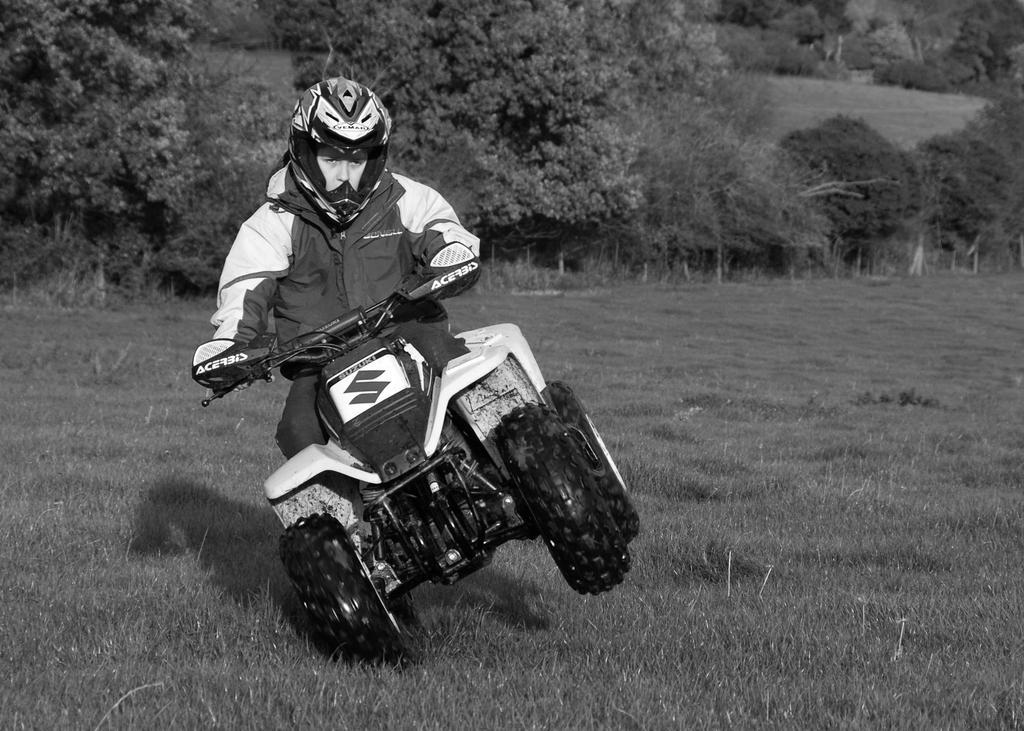In one or two sentences, can you explain what this image depicts? In this image we can see there is the person riding motorcycle and there are trees and grass. 